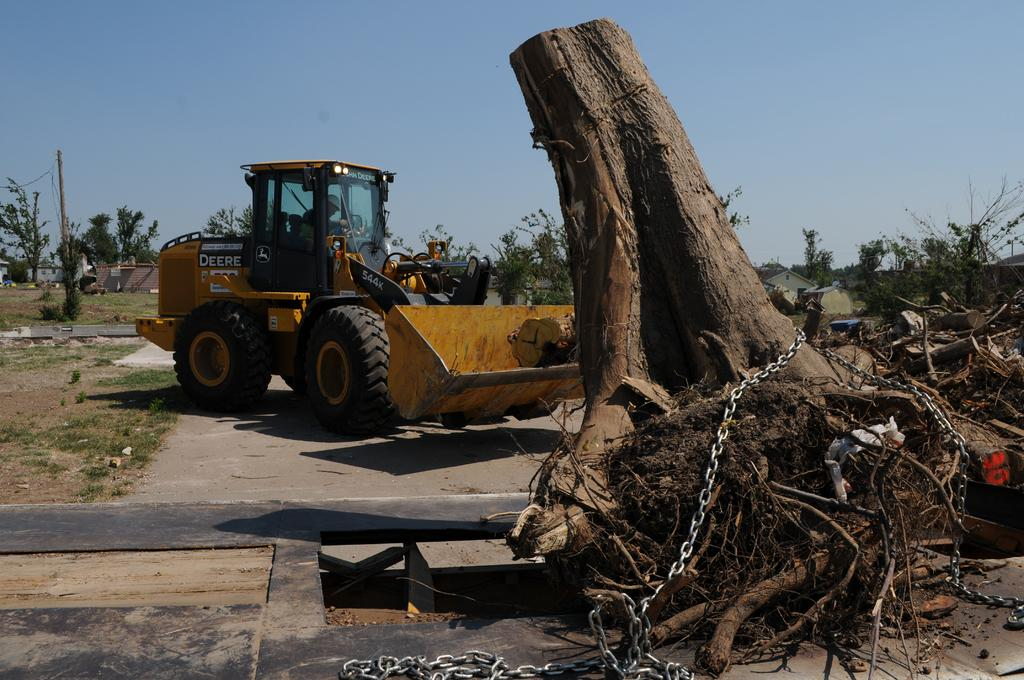What is the main object on the ground in the image? There is a vehicle on the ground in the image. What is in front of the vehicle? There is a tree trunk with a chain in front of the vehicle. What can be seen in the distance in the image? There are houses and trees visible in the background of the image. What is visible above the houses and trees in the image? The sky is visible in the background of the image. What type of cushion is being used to limit the vehicle's speed in the image? There is no cushion present in the image, nor is there any indication that the vehicle's speed is being limited. What sound does the vehicle make in the image? The image does not provide any information about the sound the vehicle makes, as it is a still image. 